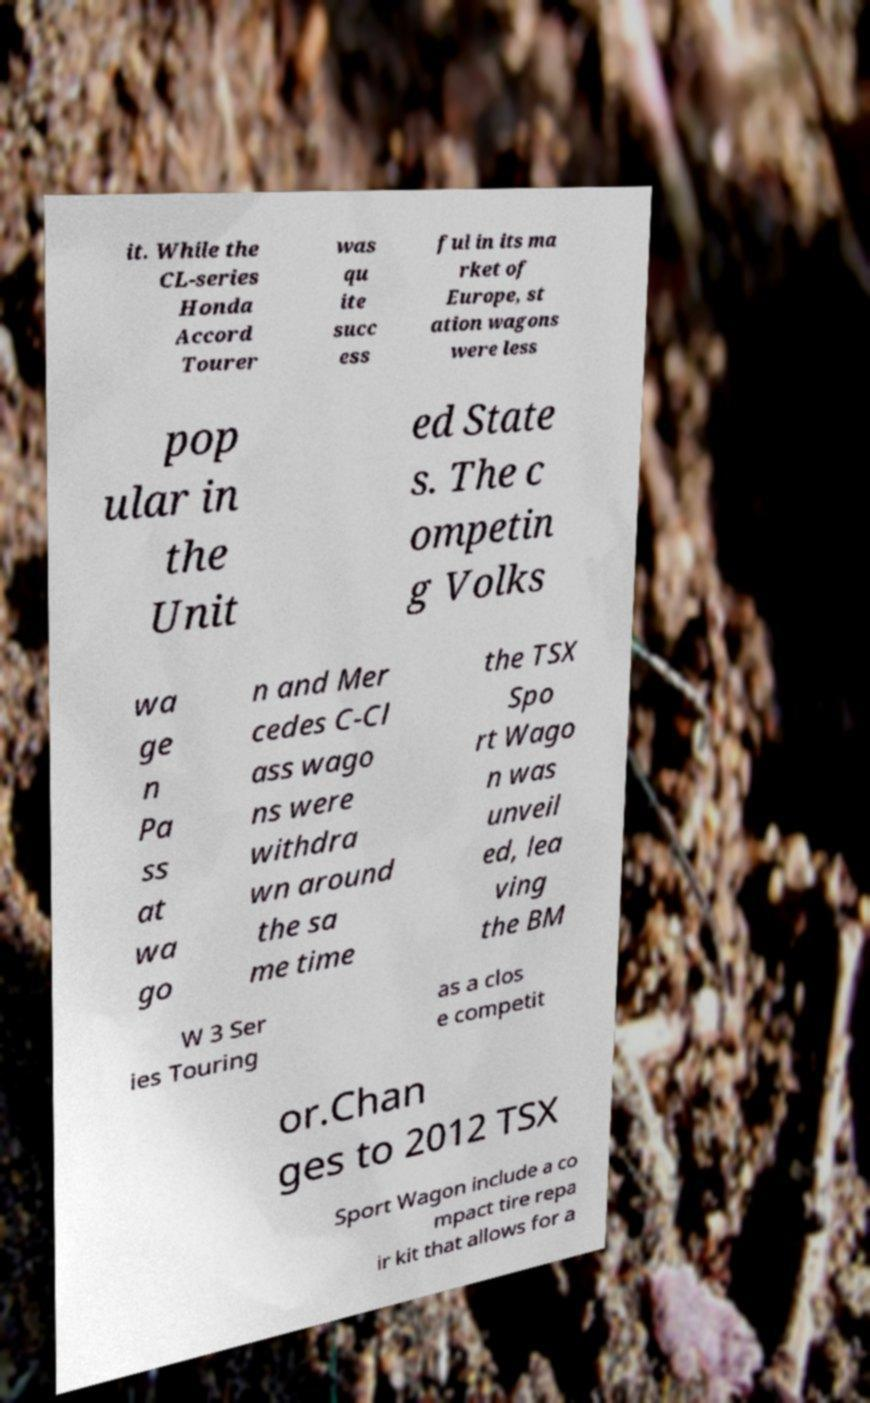Could you assist in decoding the text presented in this image and type it out clearly? it. While the CL-series Honda Accord Tourer was qu ite succ ess ful in its ma rket of Europe, st ation wagons were less pop ular in the Unit ed State s. The c ompetin g Volks wa ge n Pa ss at wa go n and Mer cedes C-Cl ass wago ns were withdra wn around the sa me time the TSX Spo rt Wago n was unveil ed, lea ving the BM W 3 Ser ies Touring as a clos e competit or.Chan ges to 2012 TSX Sport Wagon include a co mpact tire repa ir kit that allows for a 